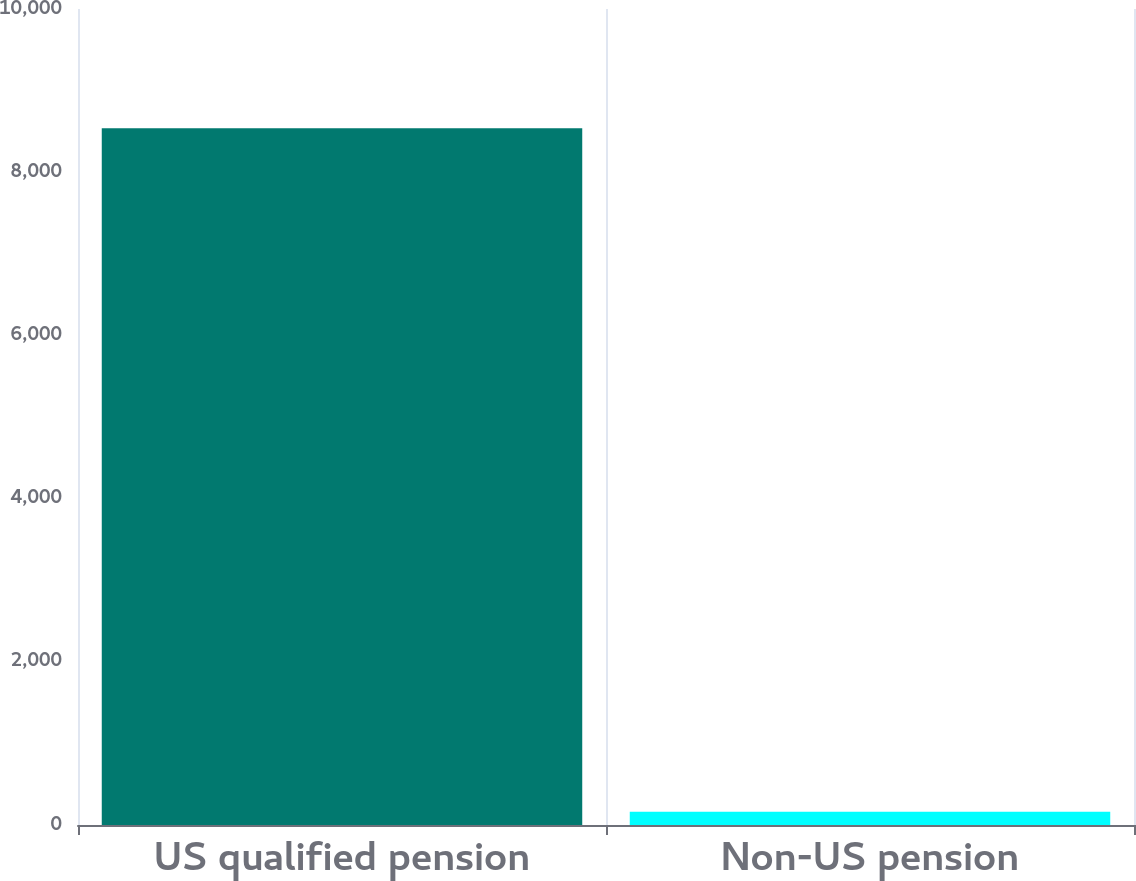<chart> <loc_0><loc_0><loc_500><loc_500><bar_chart><fcel>US qualified pension<fcel>Non-US pension<nl><fcel>8540<fcel>162<nl></chart> 